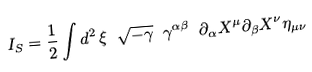Convert formula to latex. <formula><loc_0><loc_0><loc_500><loc_500>I _ { S } = \frac { 1 } { 2 } \int d ^ { 2 } \, \xi \ \sqrt { - \gamma } \ \gamma ^ { \alpha \beta } \ \partial _ { \alpha } X ^ { \mu } \partial _ { \beta } X ^ { \nu } \eta _ { \mu \nu }</formula> 